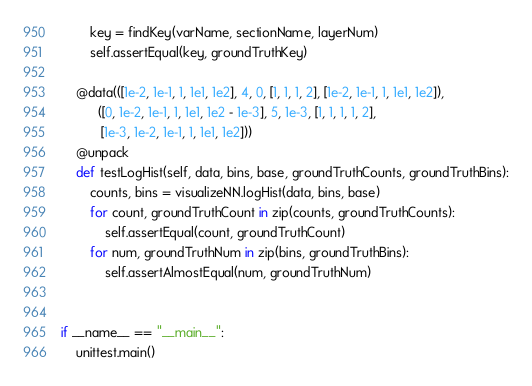Convert code to text. <code><loc_0><loc_0><loc_500><loc_500><_Python_>        key = findKey(varName, sectionName, layerNum)
        self.assertEqual(key, groundTruthKey)

    @data(([1e-2, 1e-1, 1, 1e1, 1e2], 4, 0, [1, 1, 1, 2], [1e-2, 1e-1, 1, 1e1, 1e2]),
          ([0, 1e-2, 1e-1, 1, 1e1, 1e2 - 1e-3], 5, 1e-3, [1, 1, 1, 1, 2],
           [1e-3, 1e-2, 1e-1, 1, 1e1, 1e2]))
    @unpack
    def testLogHist(self, data, bins, base, groundTruthCounts, groundTruthBins):
        counts, bins = visualizeNN.logHist(data, bins, base)
        for count, groundTruthCount in zip(counts, groundTruthCounts):
            self.assertEqual(count, groundTruthCount)
        for num, groundTruthNum in zip(bins, groundTruthBins):
            self.assertAlmostEqual(num, groundTruthNum)


if __name__ == "__main__":
    unittest.main()
</code> 